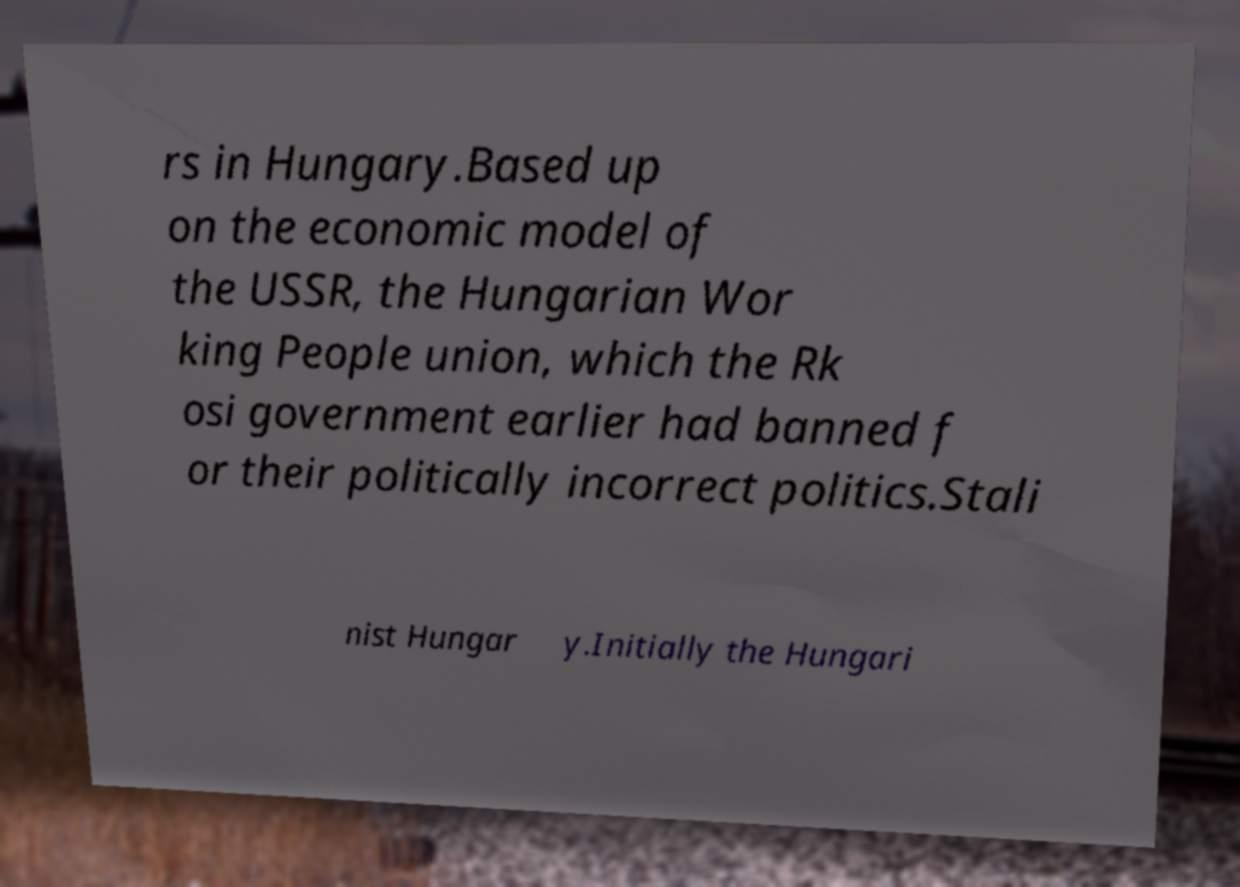There's text embedded in this image that I need extracted. Can you transcribe it verbatim? rs in Hungary.Based up on the economic model of the USSR, the Hungarian Wor king People union, which the Rk osi government earlier had banned f or their politically incorrect politics.Stali nist Hungar y.Initially the Hungari 